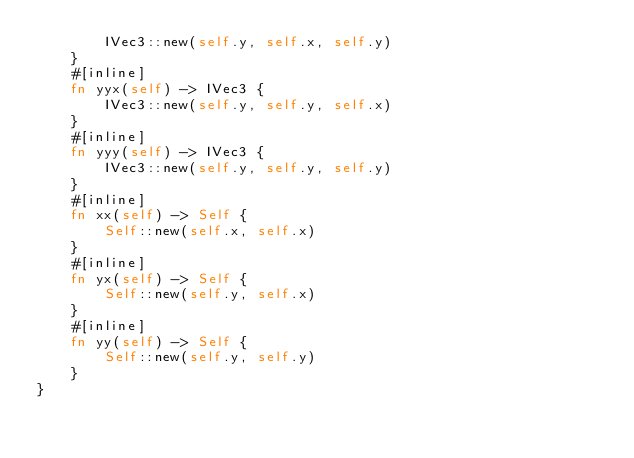<code> <loc_0><loc_0><loc_500><loc_500><_Rust_>        IVec3::new(self.y, self.x, self.y)
    }
    #[inline]
    fn yyx(self) -> IVec3 {
        IVec3::new(self.y, self.y, self.x)
    }
    #[inline]
    fn yyy(self) -> IVec3 {
        IVec3::new(self.y, self.y, self.y)
    }
    #[inline]
    fn xx(self) -> Self {
        Self::new(self.x, self.x)
    }
    #[inline]
    fn yx(self) -> Self {
        Self::new(self.y, self.x)
    }
    #[inline]
    fn yy(self) -> Self {
        Self::new(self.y, self.y)
    }
}
</code> 